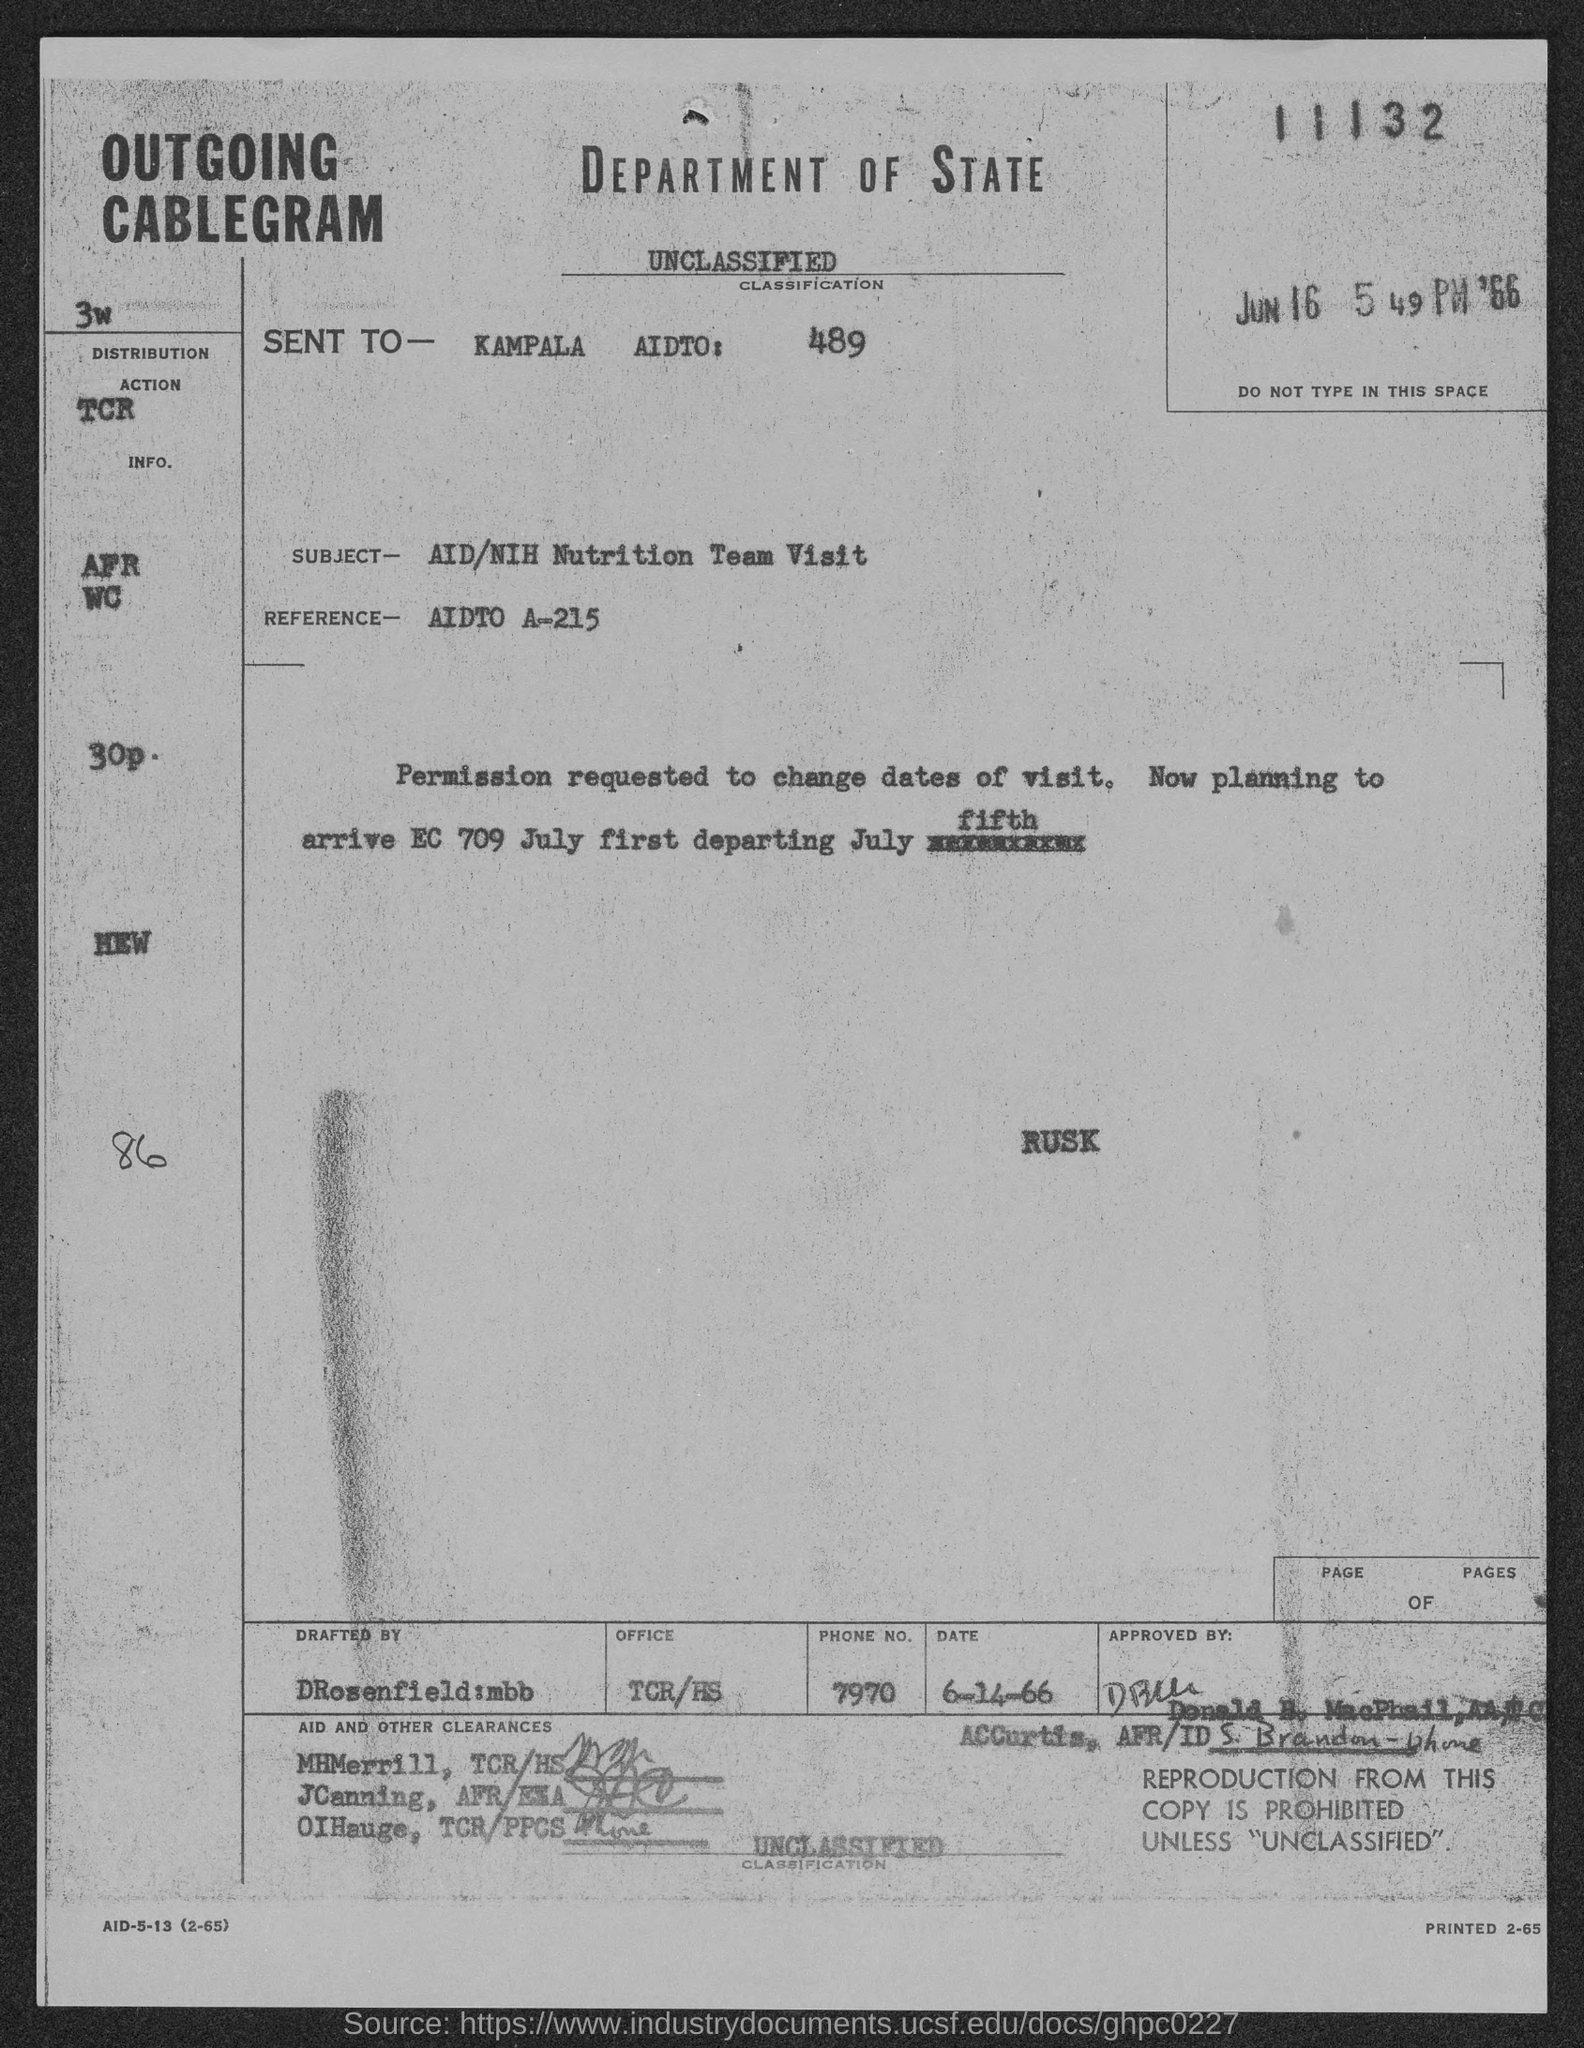What is the subject mentioned in the given page ?
Ensure brevity in your answer.  AID/NIH Nutrition Team Visit. What is the reference mentioned in the given page ?
Your answer should be compact. AIDTO A-215. What is the number mentioned at the top of the page ?
Your answer should be compact. 11132. What is the phone no. mentioned in the given form ?
Your response must be concise. 7970. By whom this form was drafted by as mentioned in the given page ?
Your response must be concise. DRosenfield:mbb. 